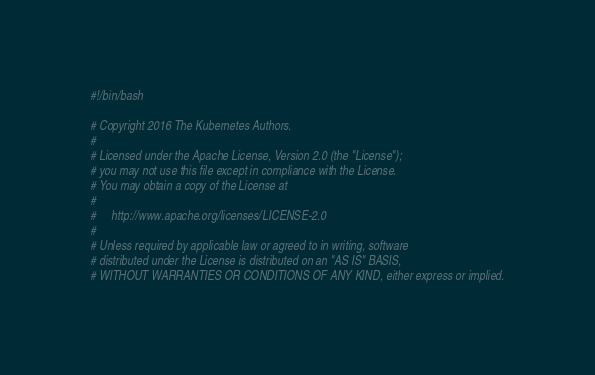<code> <loc_0><loc_0><loc_500><loc_500><_Bash_>#!/bin/bash

# Copyright 2016 The Kubernetes Authors.
#
# Licensed under the Apache License, Version 2.0 (the "License");
# you may not use this file except in compliance with the License.
# You may obtain a copy of the License at
#
#     http://www.apache.org/licenses/LICENSE-2.0
#
# Unless required by applicable law or agreed to in writing, software
# distributed under the License is distributed on an "AS IS" BASIS,
# WITHOUT WARRANTIES OR CONDITIONS OF ANY KIND, either express or implied.</code> 